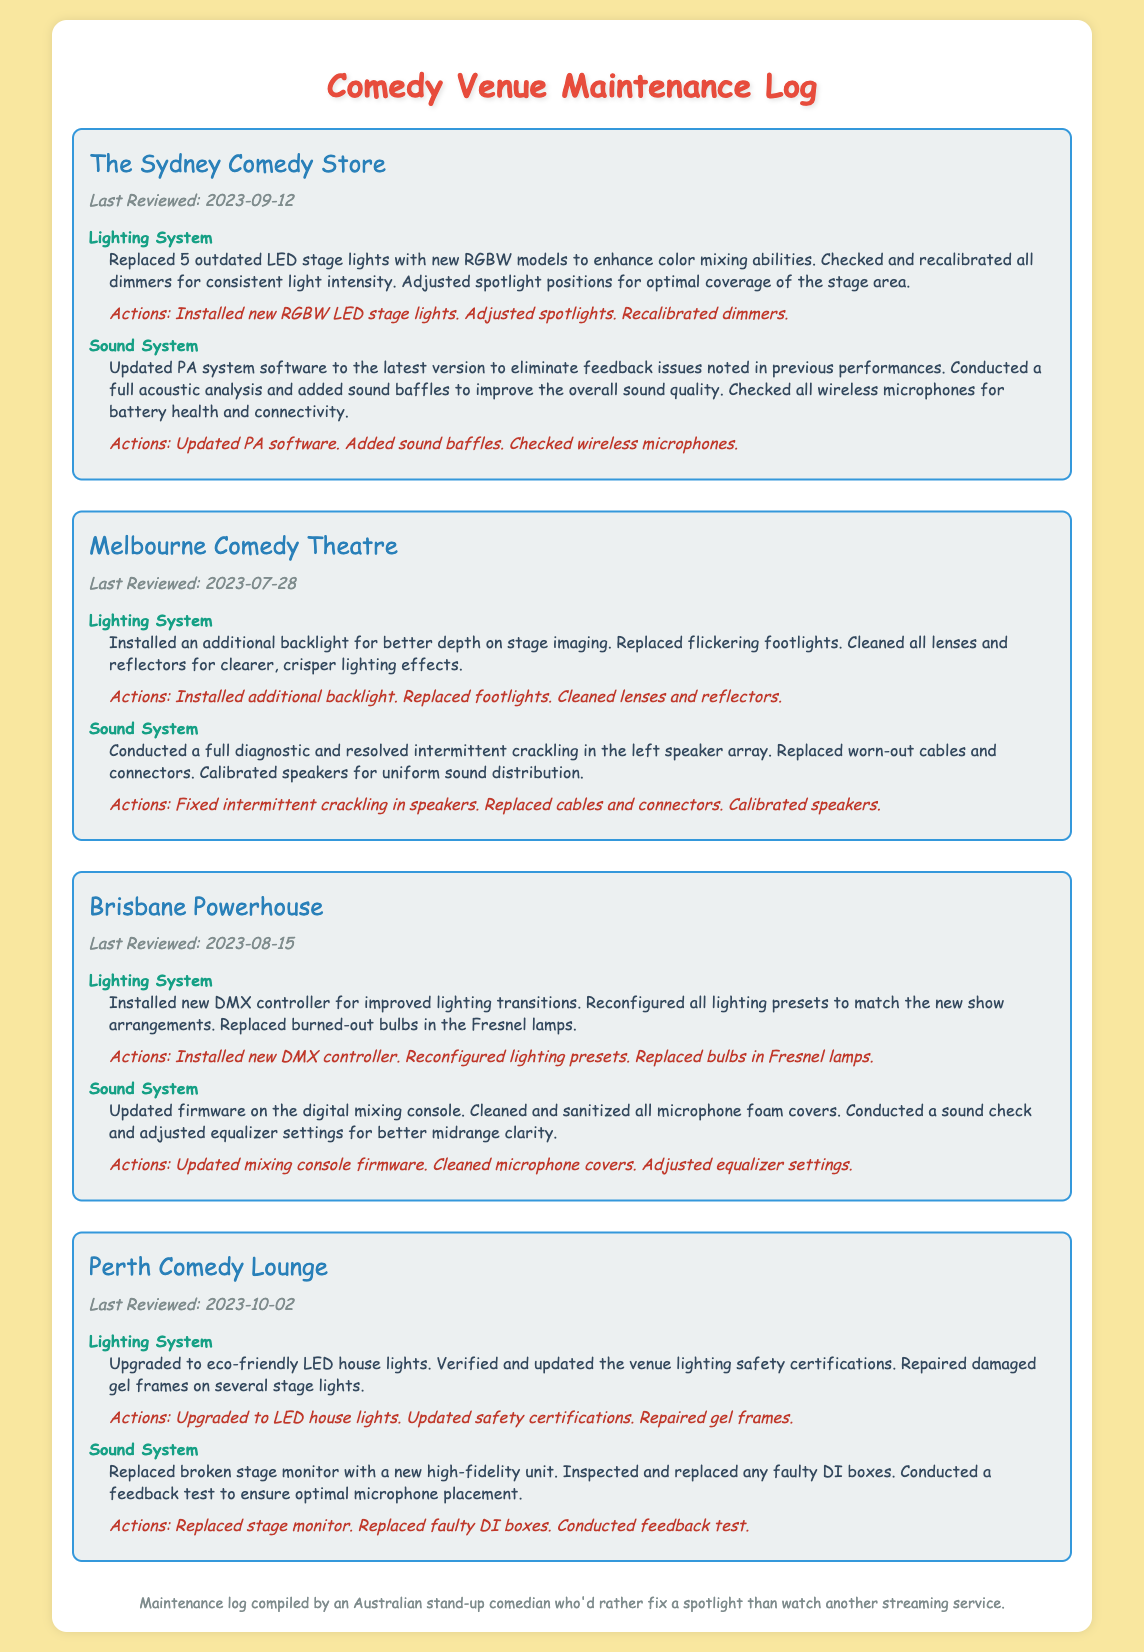what is the last reviewed date for The Sydney Comedy Store? The last reviewed date is provided in the document under each venue's section. For The Sydney Comedy Store, it is 2023-09-12.
Answer: 2023-09-12 how many outdated LED stage lights were replaced at The Sydney Comedy Store? The number of outdated LED stage lights replaced is specified in the details section for The Sydney Comedy Store. It mentions 5 lights were replaced.
Answer: 5 which venue had a backlight installed for better stage imaging? The venue that had an additional backlight installed is mentioned under the Lighting System section in the Melbourne Comedy Theatre's details.
Answer: Melbourne Comedy Theatre what actions were taken to improve the sound quality at the Brisbane Powerhouse? The actions taken to improve the sound quality include updating firmware, cleaning microphone covers, and adjusting equalizer settings, as listed under the Sound System section.
Answer: Updated mixing console firmware, cleaned microphone covers, adjusted equalizer settings how many actions were listed for the lighting system maintenance at the Perth Comedy Lounge? The actions listed for the lighting system maintenance at the Perth Comedy Lounge can be counted under the Lighting System section, which includes three actions.
Answer: 3 what system was updated at the Melbourne Comedy Theatre to resolve speaker issues? The system that was updated to resolve speaker issues is specified in the Sound System section, mentioning a full diagnostic was conducted to address crackling.
Answer: Sound System which comedy venue upgraded to eco-friendly house lights? The venue that upgraded to eco-friendly LED house lights is noted under the Lighting System section for the Perth Comedy Lounge.
Answer: Perth Comedy Lounge what is the main focus of this maintenance log? The main focus of the maintenance log is indicated in the title, concerning the maintenance details of comedy performance venues, specifically regarding lighting and sound systems.
Answer: Comedy performance venues what was the main action performed on the PA system at The Sydney Comedy Store? The main action performed on the PA system is mentioned under the Sound System topic, stating that the software was updated to eliminate feedback issues.
Answer: Updated PA software 